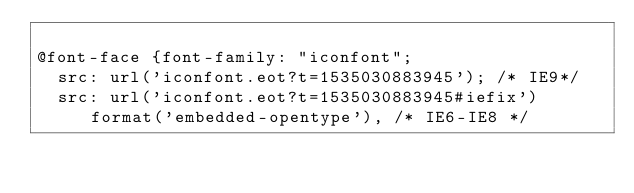<code> <loc_0><loc_0><loc_500><loc_500><_CSS_>
@font-face {font-family: "iconfont";
  src: url('iconfont.eot?t=1535030883945'); /* IE9*/
  src: url('iconfont.eot?t=1535030883945#iefix') format('embedded-opentype'), /* IE6-IE8 */</code> 